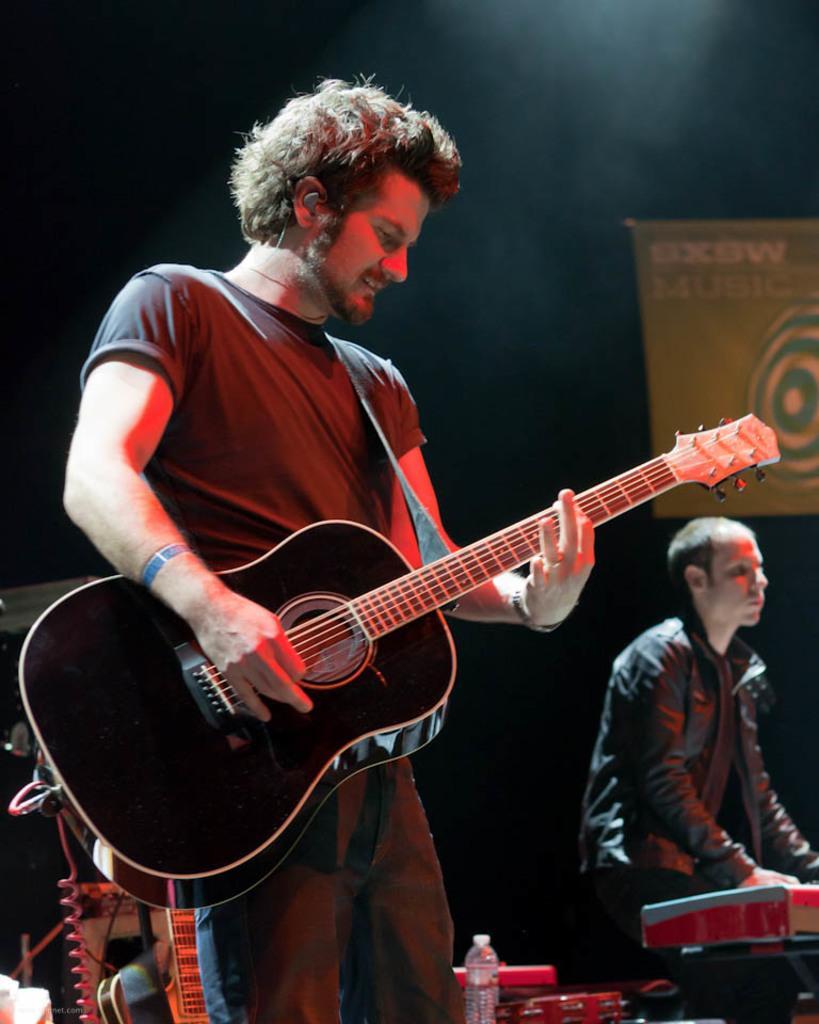In one or two sentences, can you explain what this image depicts? They are both standing and they are both playing musical instruments. 